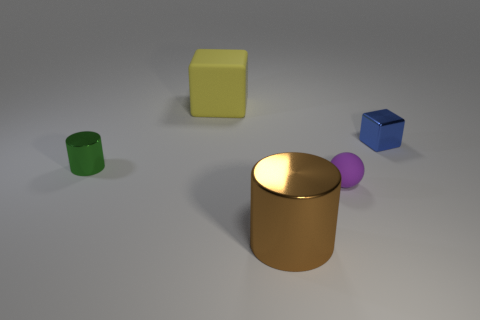Add 4 small yellow shiny cylinders. How many objects exist? 9 Subtract all cylinders. How many objects are left? 3 Add 4 tiny green rubber objects. How many tiny green rubber objects exist? 4 Subtract 1 blue cubes. How many objects are left? 4 Subtract all matte things. Subtract all brown balls. How many objects are left? 3 Add 1 large matte things. How many large matte things are left? 2 